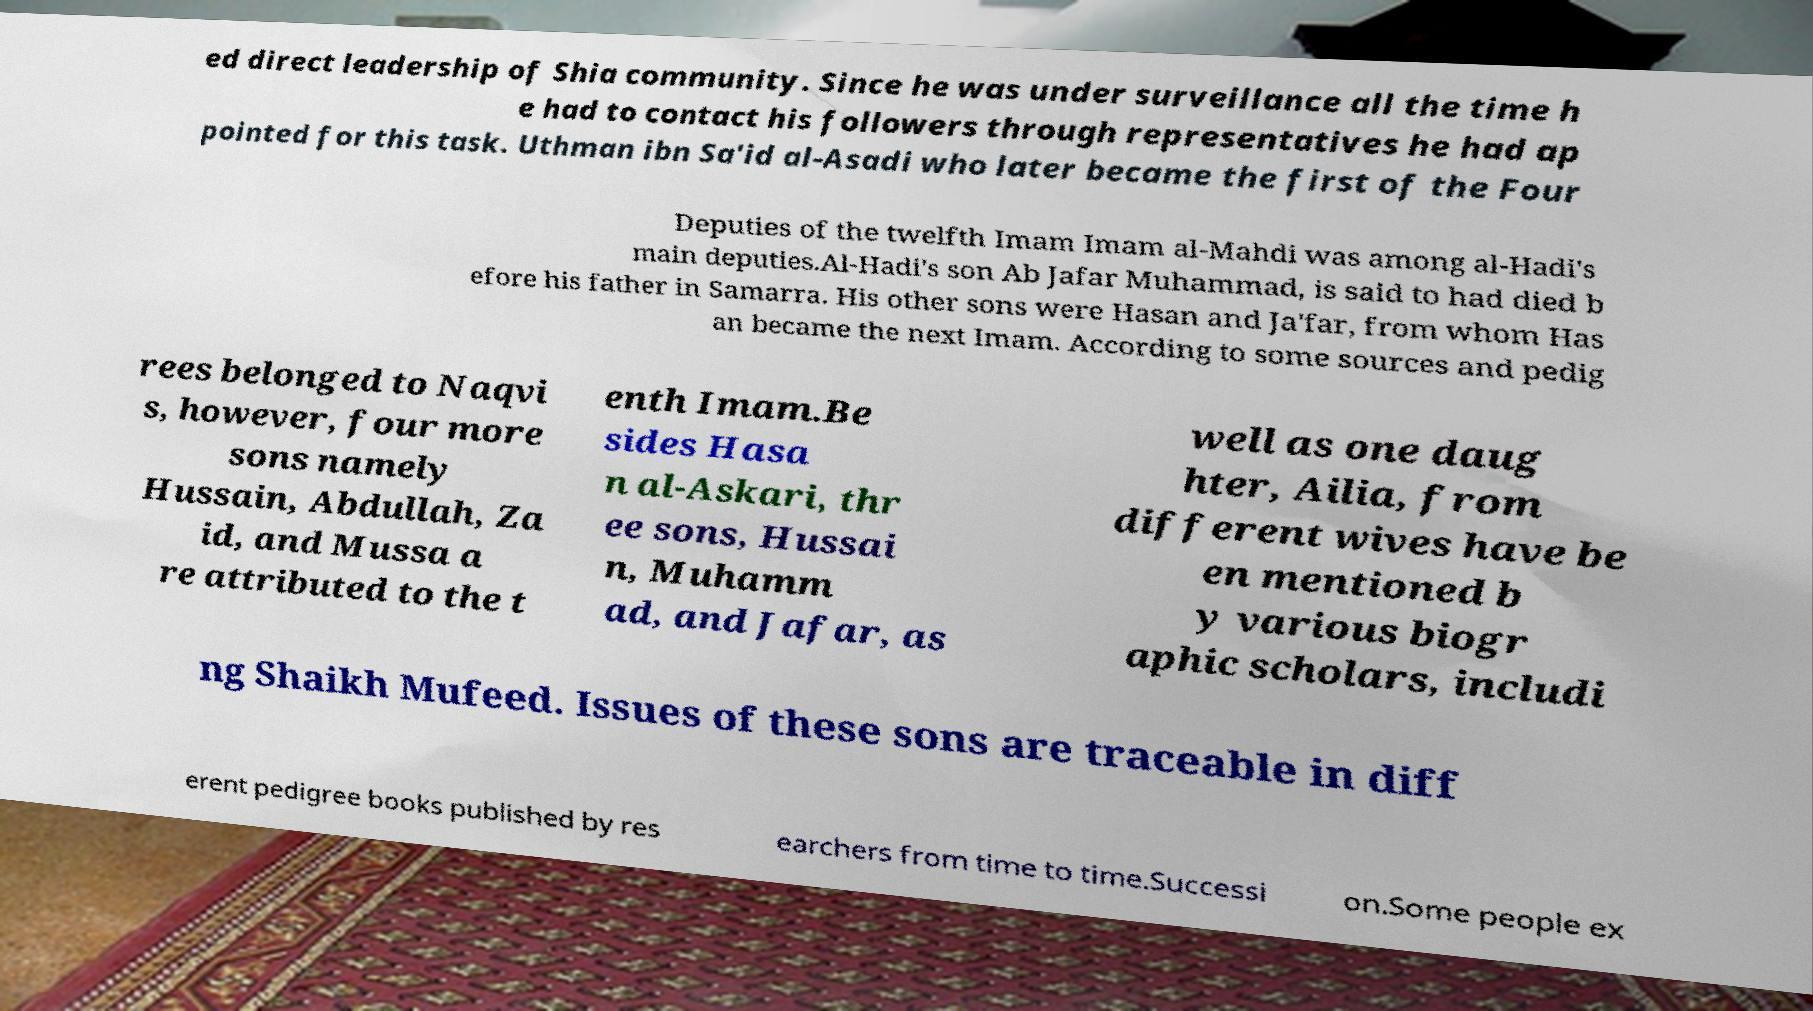For documentation purposes, I need the text within this image transcribed. Could you provide that? ed direct leadership of Shia community. Since he was under surveillance all the time h e had to contact his followers through representatives he had ap pointed for this task. Uthman ibn Sa'id al-Asadi who later became the first of the Four Deputies of the twelfth Imam Imam al-Mahdi was among al-Hadi's main deputies.Al-Hadi's son Ab Jafar Muhammad, is said to had died b efore his father in Samarra. His other sons were Hasan and Ja'far, from whom Has an became the next Imam. According to some sources and pedig rees belonged to Naqvi s, however, four more sons namely Hussain, Abdullah, Za id, and Mussa a re attributed to the t enth Imam.Be sides Hasa n al-Askari, thr ee sons, Hussai n, Muhamm ad, and Jafar, as well as one daug hter, Ailia, from different wives have be en mentioned b y various biogr aphic scholars, includi ng Shaikh Mufeed. Issues of these sons are traceable in diff erent pedigree books published by res earchers from time to time.Successi on.Some people ex 